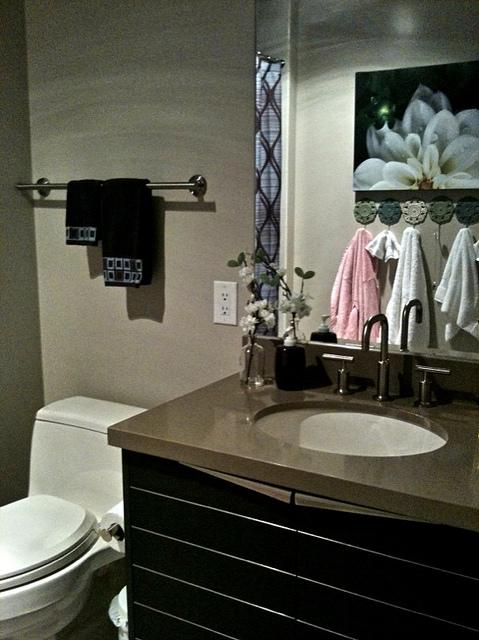What is likely opposite the toilet?

Choices:
A) closet
B) bedroom door
C) bathtub
D) vanity bathtub 